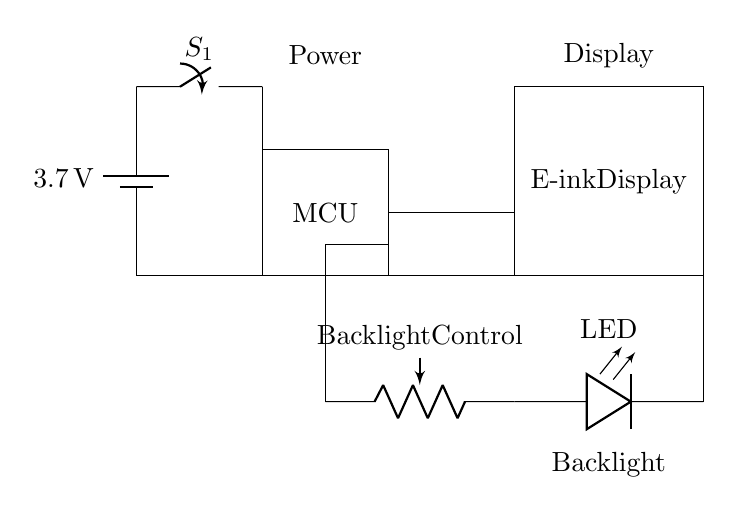What is the main power source for the circuit? The main power source is a battery, which is indicated in the circuit diagram and labeled with a voltage of 3.7 volts.
Answer: battery What is the function of the switch in this circuit? The switch serves to control the power flow from the battery to the rest of the circuit, allowing the user to turn the device on or off as needed.
Answer: power control How many components are connected to the microcontroller? Three components are connected to the microcontroller: the power switch, the potentiometer, and the e-ink display.
Answer: three What type of component is used for backlight control? A potentiometer is used for backlight control in this circuit, allowing the user to adjust the brightness of the LED backlight.
Answer: potentiometer What is the output device in this circuit? The output device in this circuit is the e-ink display, which is used to render images and text for the user.
Answer: e-ink display How does the potentiometer affect the LED? The potentiometer varies the resistance in the circuit, adjusting the current flowing through the LED, which in turn controls the brightness of the backlight.
Answer: brightness control What type of display is used in this e-reader circuit? An e-ink display is used in this circuit, which is known for its low power consumption and good readability in various lighting conditions.
Answer: e-ink display 